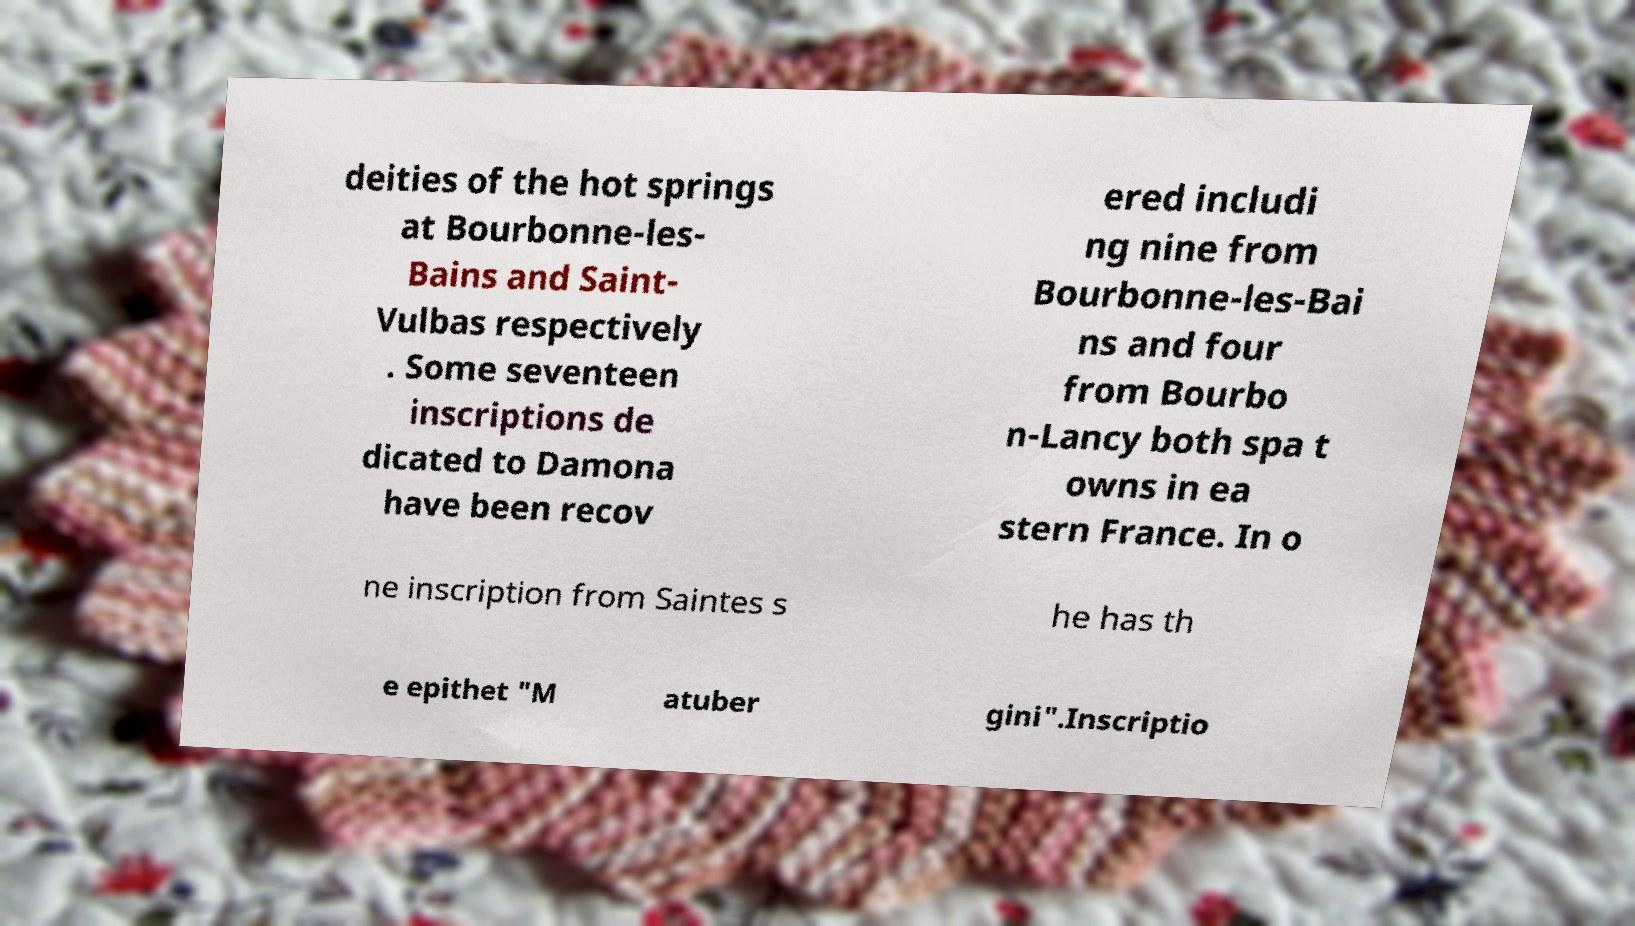Please identify and transcribe the text found in this image. deities of the hot springs at Bourbonne-les- Bains and Saint- Vulbas respectively . Some seventeen inscriptions de dicated to Damona have been recov ered includi ng nine from Bourbonne-les-Bai ns and four from Bourbo n-Lancy both spa t owns in ea stern France. In o ne inscription from Saintes s he has th e epithet "M atuber gini".Inscriptio 